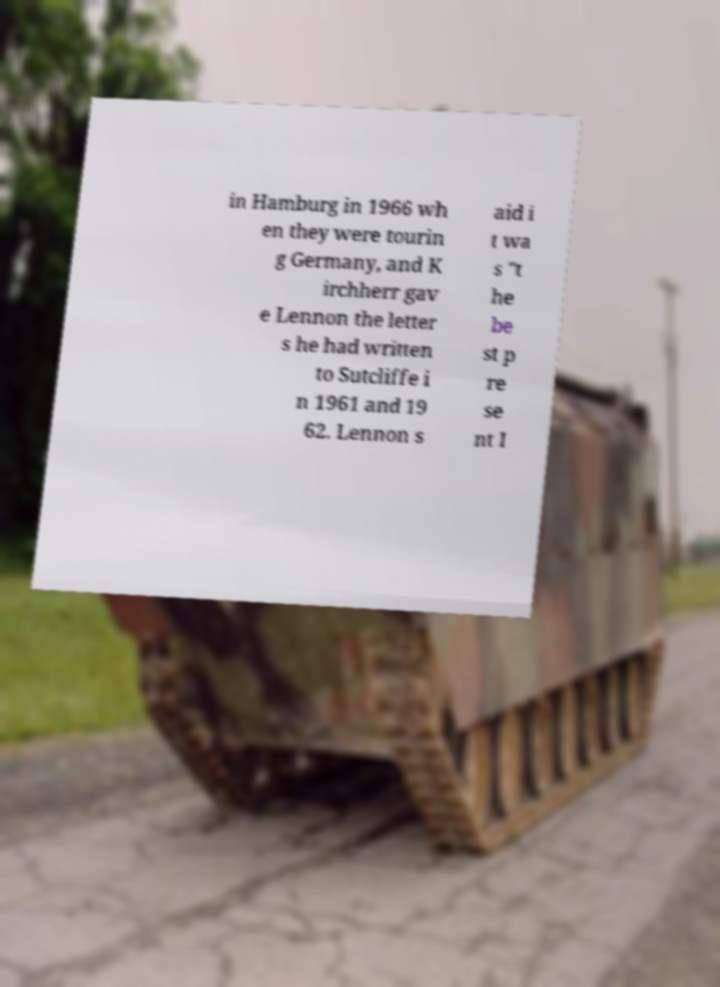Please read and relay the text visible in this image. What does it say? in Hamburg in 1966 wh en they were tourin g Germany, and K irchherr gav e Lennon the letter s he had written to Sutcliffe i n 1961 and 19 62. Lennon s aid i t wa s "t he be st p re se nt I 